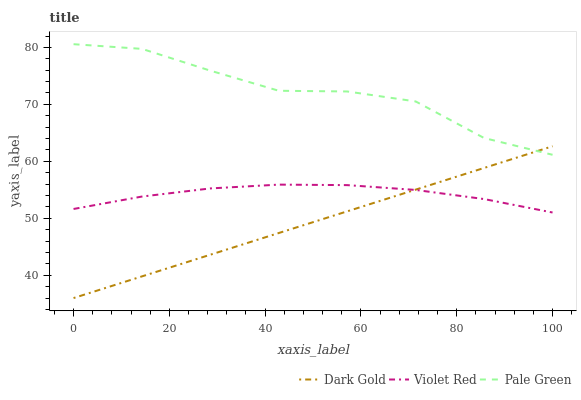Does Dark Gold have the minimum area under the curve?
Answer yes or no. Yes. Does Pale Green have the maximum area under the curve?
Answer yes or no. Yes. Does Pale Green have the minimum area under the curve?
Answer yes or no. No. Does Dark Gold have the maximum area under the curve?
Answer yes or no. No. Is Dark Gold the smoothest?
Answer yes or no. Yes. Is Pale Green the roughest?
Answer yes or no. Yes. Is Pale Green the smoothest?
Answer yes or no. No. Is Dark Gold the roughest?
Answer yes or no. No. Does Dark Gold have the lowest value?
Answer yes or no. Yes. Does Pale Green have the lowest value?
Answer yes or no. No. Does Pale Green have the highest value?
Answer yes or no. Yes. Does Dark Gold have the highest value?
Answer yes or no. No. Is Violet Red less than Pale Green?
Answer yes or no. Yes. Is Pale Green greater than Violet Red?
Answer yes or no. Yes. Does Pale Green intersect Dark Gold?
Answer yes or no. Yes. Is Pale Green less than Dark Gold?
Answer yes or no. No. Is Pale Green greater than Dark Gold?
Answer yes or no. No. Does Violet Red intersect Pale Green?
Answer yes or no. No. 